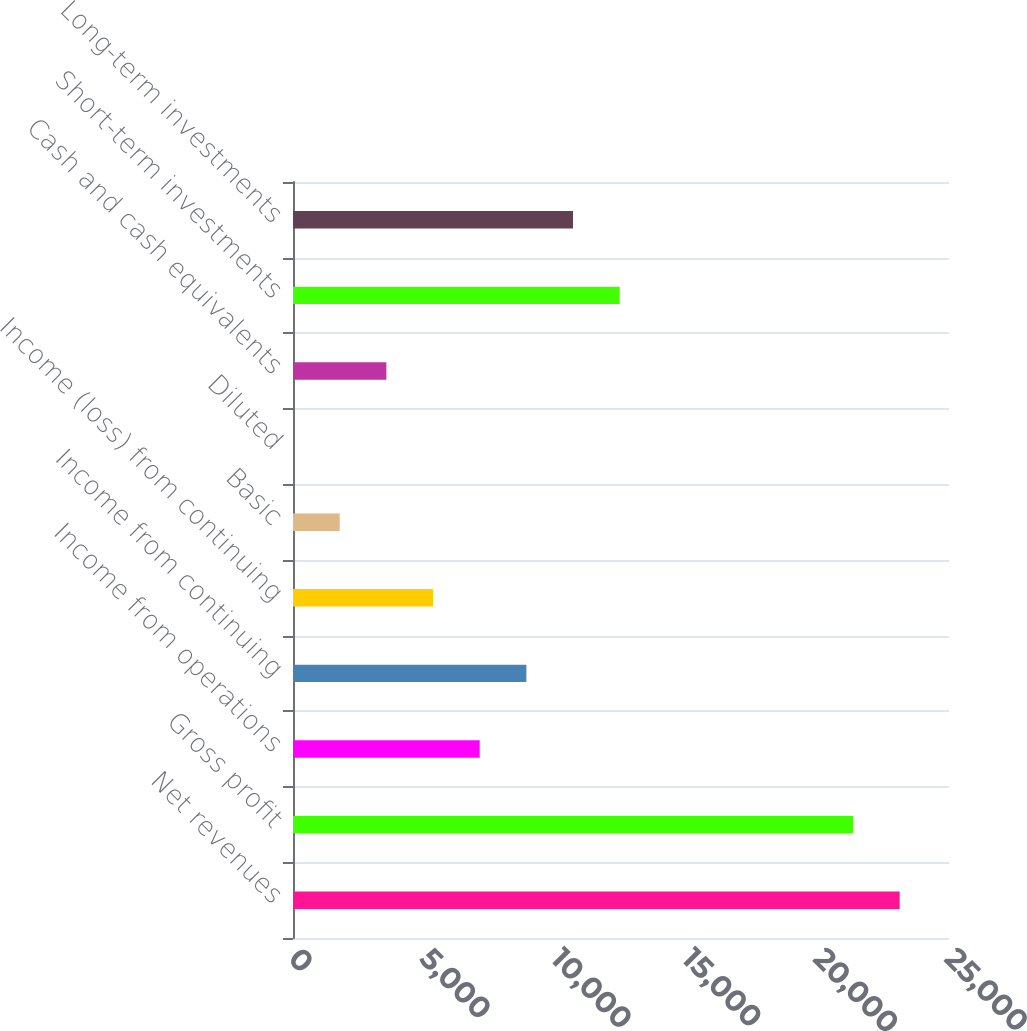Convert chart to OTSL. <chart><loc_0><loc_0><loc_500><loc_500><bar_chart><fcel>Net revenues<fcel>Gross profit<fcel>Income from operations<fcel>Income from continuing<fcel>Income (loss) from continuing<fcel>Basic<fcel>Diluted<fcel>Cash and cash equivalents<fcel>Short-term investments<fcel>Long-term investments<nl><fcel>23120<fcel>21341.7<fcel>7114.96<fcel>8893.3<fcel>5336.62<fcel>1779.94<fcel>1.6<fcel>3558.28<fcel>12450<fcel>10671.6<nl></chart> 